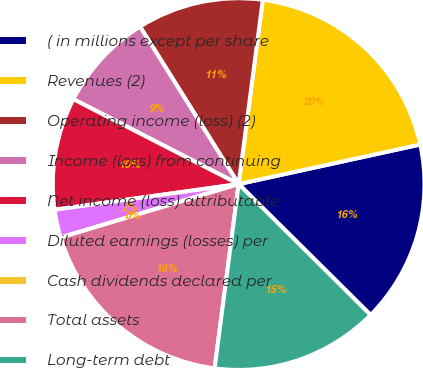Convert chart. <chart><loc_0><loc_0><loc_500><loc_500><pie_chart><fcel>( in millions except per share<fcel>Revenues (2)<fcel>Operating income (loss) (2)<fcel>Income (loss) from continuing<fcel>Net income (loss) attributable<fcel>Diluted earnings (losses) per<fcel>Cash dividends declared per<fcel>Total assets<fcel>Long-term debt<nl><fcel>15.85%<fcel>19.51%<fcel>10.98%<fcel>8.54%<fcel>9.76%<fcel>2.44%<fcel>0.0%<fcel>18.29%<fcel>14.63%<nl></chart> 